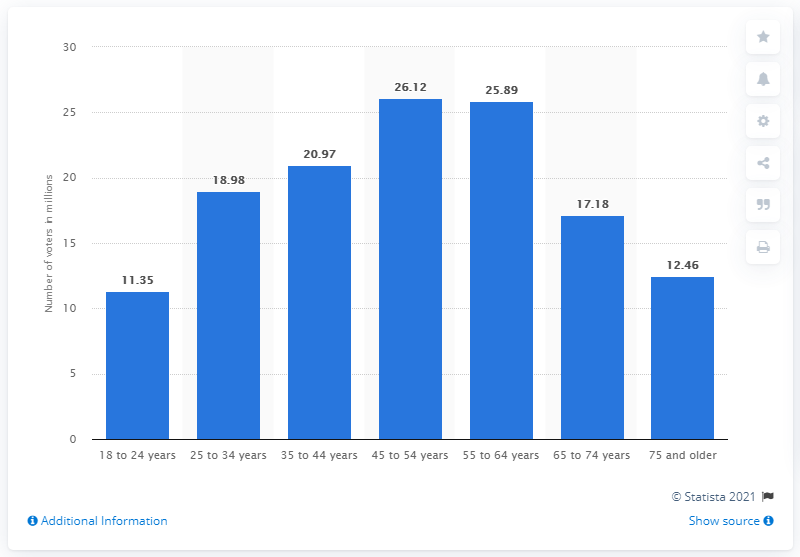List a handful of essential elements in this visual. According to data from 2012, there were 11.35 million voters between the ages of 18 and 24. 